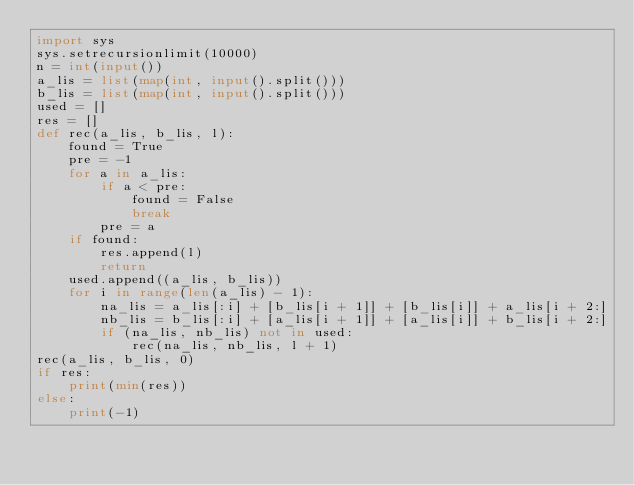<code> <loc_0><loc_0><loc_500><loc_500><_Python_>import sys
sys.setrecursionlimit(10000)
n = int(input())
a_lis = list(map(int, input().split()))
b_lis = list(map(int, input().split()))
used = []
res = []
def rec(a_lis, b_lis, l):
    found = True
    pre = -1
    for a in a_lis:
        if a < pre:
            found = False
            break
        pre = a
    if found:
        res.append(l)
        return
    used.append((a_lis, b_lis))
    for i in range(len(a_lis) - 1):
        na_lis = a_lis[:i] + [b_lis[i + 1]] + [b_lis[i]] + a_lis[i + 2:]
        nb_lis = b_lis[:i] + [a_lis[i + 1]] + [a_lis[i]] + b_lis[i + 2:]
        if (na_lis, nb_lis) not in used:
            rec(na_lis, nb_lis, l + 1)
rec(a_lis, b_lis, 0)
if res:
    print(min(res))
else:
    print(-1)    </code> 